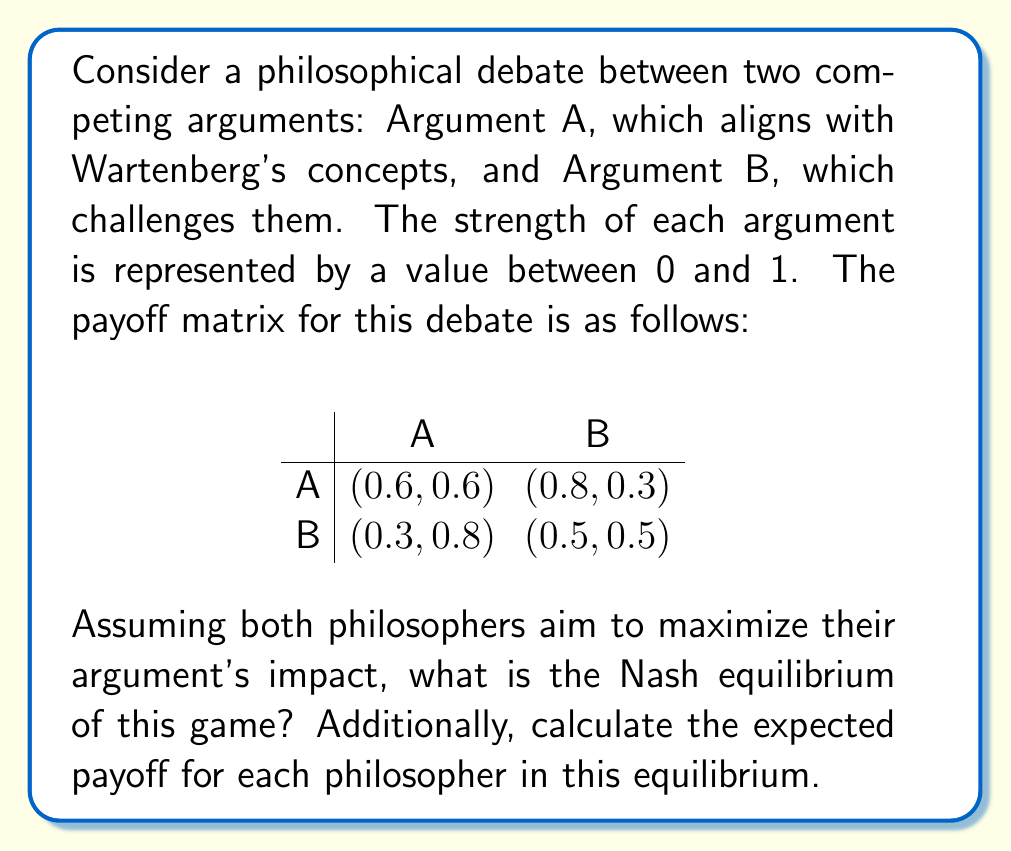Can you answer this question? To solve this game theory problem, we need to follow these steps:

1. Identify the dominant strategies for each philosopher (if any).
2. If there are no dominant strategies, find the best responses for each philosopher.
3. Determine the Nash equilibrium based on the best responses.
4. Calculate the expected payoff for each philosopher in the equilibrium.

Step 1: Identifying dominant strategies

For Philosopher A:
- If B chooses A: 0.6 > 0.3, so A prefers A
- If B chooses B: 0.8 > 0.5, so A prefers A
A has a dominant strategy: always choose A

For Philosopher B:
- If A chooses A: 0.6 < 0.8, so B prefers B
- If A chooses B: 0.3 < 0.5, so B prefers B
B has a dominant strategy: always choose B

Step 2: Best responses
Since both philosophers have dominant strategies, the best responses are:
- Philosopher A: Always choose A
- Philosopher B: Always choose B

Step 3: Nash equilibrium
The Nash equilibrium is (A, B), where Philosopher A chooses Argument A and Philosopher B chooses Argument B.

Step 4: Expected payoffs
In the Nash equilibrium (A, B), the payoffs are:
- Philosopher A: 0.8
- Philosopher B: 0.3

Therefore, the Nash equilibrium is (A, B) with expected payoffs (0.8, 0.3).
Answer: The Nash equilibrium is (A, B) with expected payoffs (0.8, 0.3). 